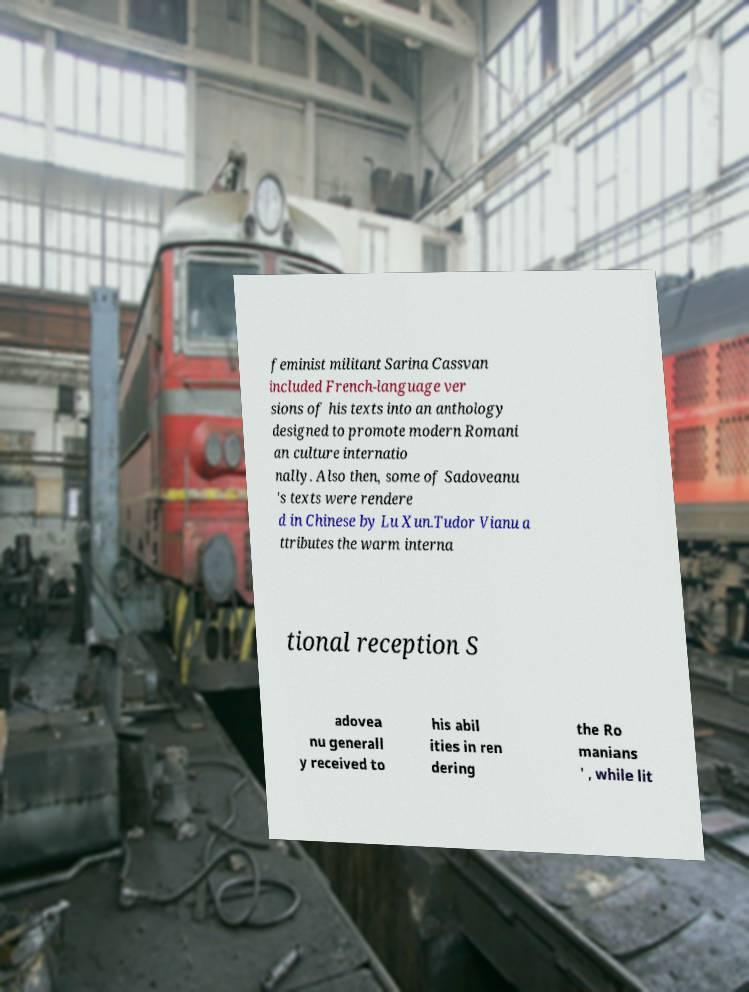Please identify and transcribe the text found in this image. feminist militant Sarina Cassvan included French-language ver sions of his texts into an anthology designed to promote modern Romani an culture internatio nally. Also then, some of Sadoveanu 's texts were rendere d in Chinese by Lu Xun.Tudor Vianu a ttributes the warm interna tional reception S adovea nu generall y received to his abil ities in ren dering the Ro manians ' , while lit 